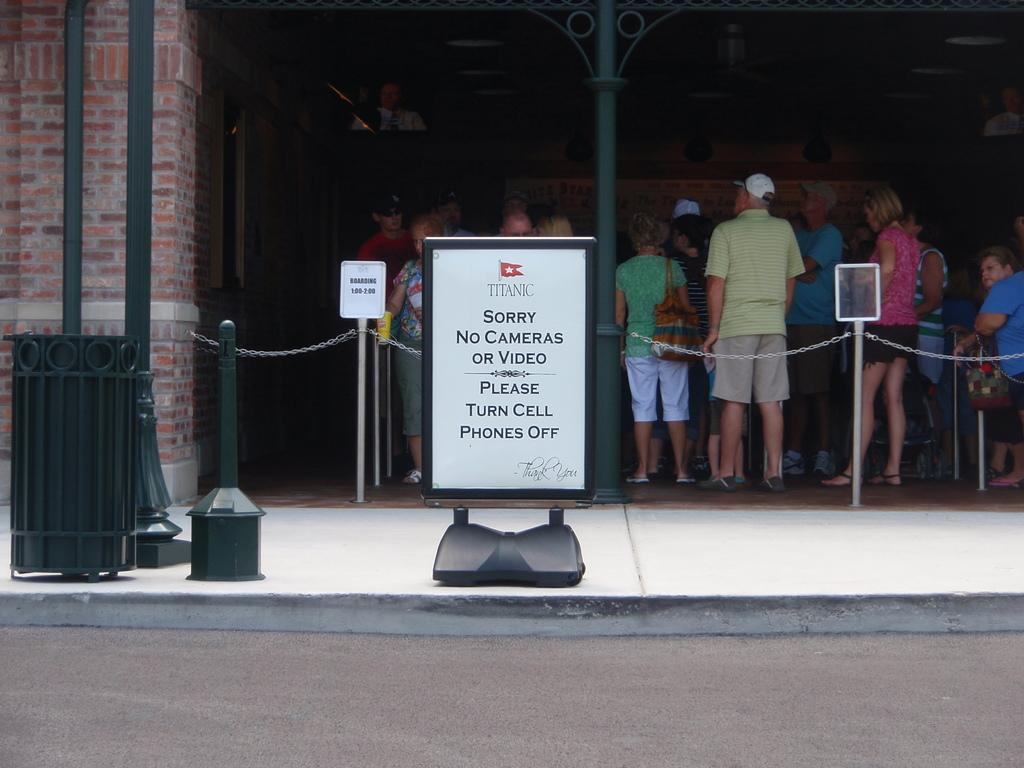What is the main feature of the image? There is a road in the image. What else can be seen in the image besides the road? There is a board and poles visible in the image. What is happening in the background of the image? There are people standing in line in the background of the image. What structure can be seen in the background? There is a wall in the background of the image. What type of coil is being used by the people standing in line in the image? There is no coil present in the image; the people are simply standing in line. What is the relationship between the people in the image? The provided facts do not mention any relationships between the people in the image, so we cannot determine if they are brothers or any other type of relation. 